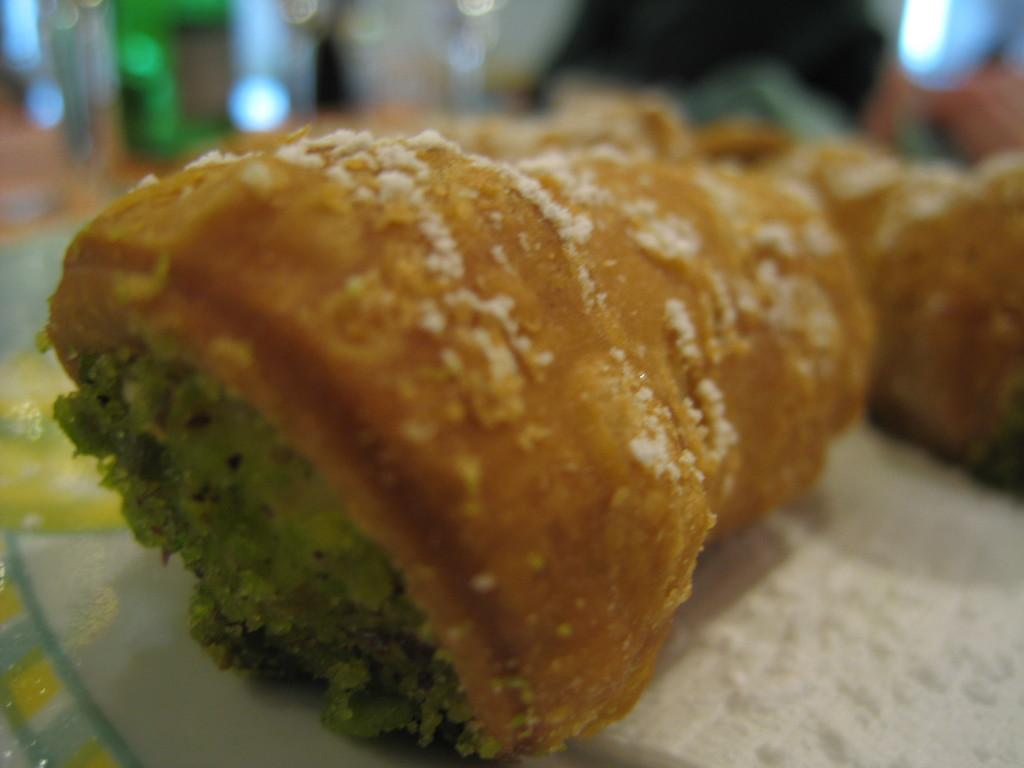What is present in the image? There is food in the image. Can you describe the background of the image? The background of the image is blurry. What type of soap is being used to prepare the cheese in the image? There is no soap or cheese present in the image; it only features food and a blurry background. 